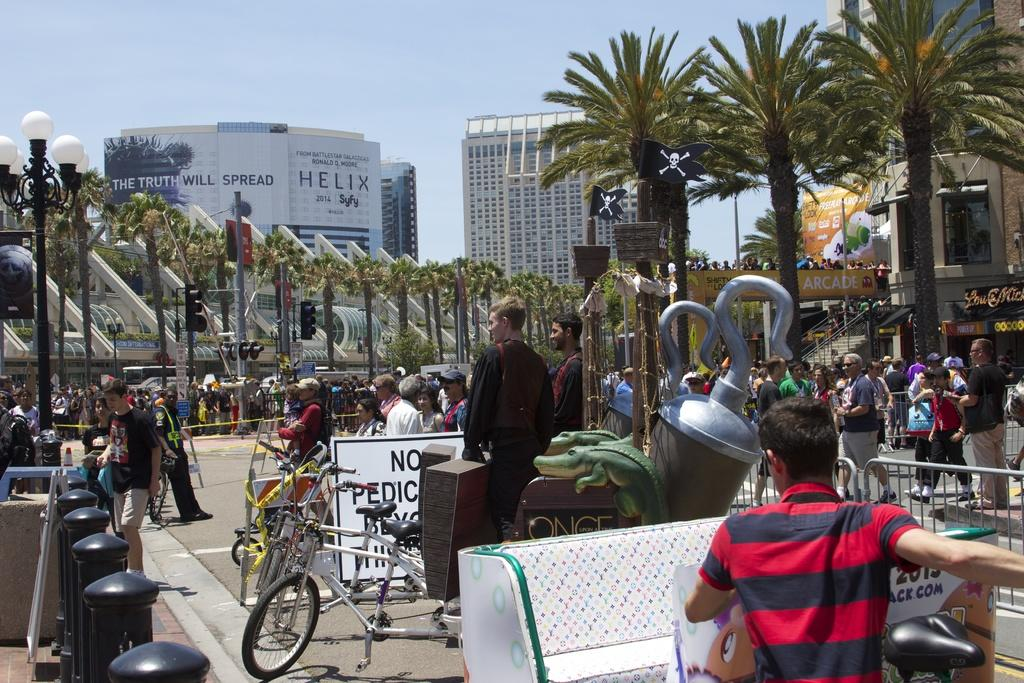<image>
Render a clear and concise summary of the photo. a town with a building that has the word Helix on it 